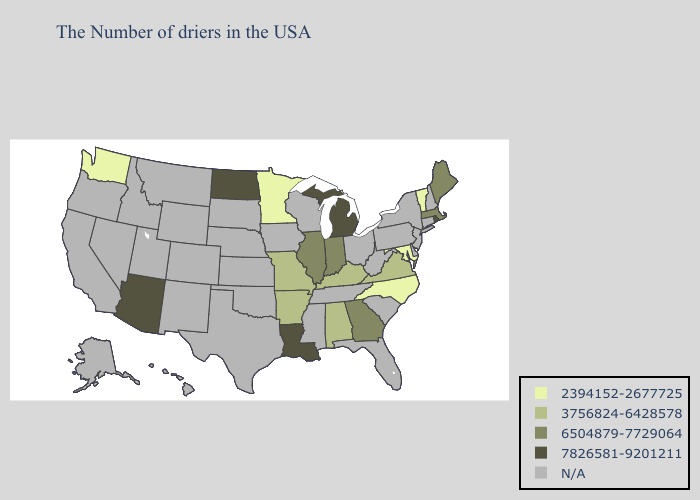Does Arkansas have the lowest value in the South?
Write a very short answer. No. Name the states that have a value in the range 7826581-9201211?
Give a very brief answer. Rhode Island, Michigan, Louisiana, North Dakota, Arizona. What is the lowest value in states that border Oregon?
Concise answer only. 2394152-2677725. What is the value of North Carolina?
Concise answer only. 2394152-2677725. Name the states that have a value in the range 7826581-9201211?
Be succinct. Rhode Island, Michigan, Louisiana, North Dakota, Arizona. What is the value of Pennsylvania?
Short answer required. N/A. Does Rhode Island have the highest value in the Northeast?
Be succinct. Yes. Among the states that border Virginia , which have the highest value?
Write a very short answer. Kentucky. Does the map have missing data?
Concise answer only. Yes. Name the states that have a value in the range N/A?
Quick response, please. New Hampshire, Connecticut, New York, New Jersey, Delaware, Pennsylvania, South Carolina, West Virginia, Ohio, Florida, Tennessee, Wisconsin, Mississippi, Iowa, Kansas, Nebraska, Oklahoma, Texas, South Dakota, Wyoming, Colorado, New Mexico, Utah, Montana, Idaho, Nevada, California, Oregon, Alaska, Hawaii. What is the highest value in the USA?
Write a very short answer. 7826581-9201211. What is the value of Kentucky?
Quick response, please. 3756824-6428578. Does the first symbol in the legend represent the smallest category?
Give a very brief answer. Yes. Does the first symbol in the legend represent the smallest category?
Write a very short answer. Yes. What is the lowest value in states that border Kentucky?
Be succinct. 3756824-6428578. 